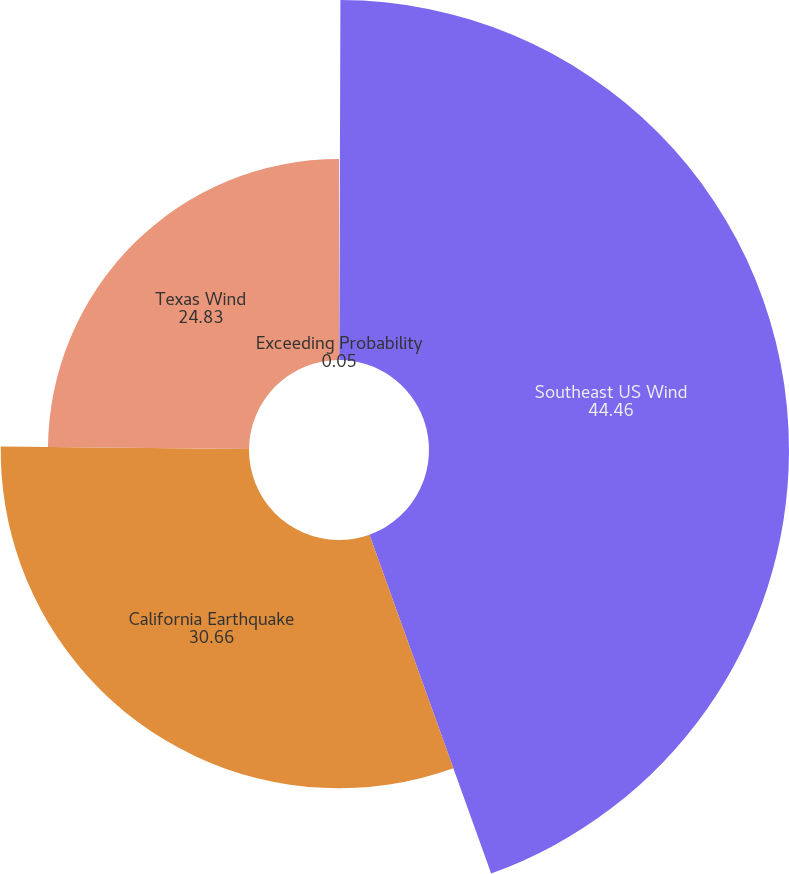Convert chart. <chart><loc_0><loc_0><loc_500><loc_500><pie_chart><fcel>Exceeding Probability<fcel>Southeast US Wind<fcel>California Earthquake<fcel>Texas Wind<nl><fcel>0.05%<fcel>44.46%<fcel>30.66%<fcel>24.83%<nl></chart> 